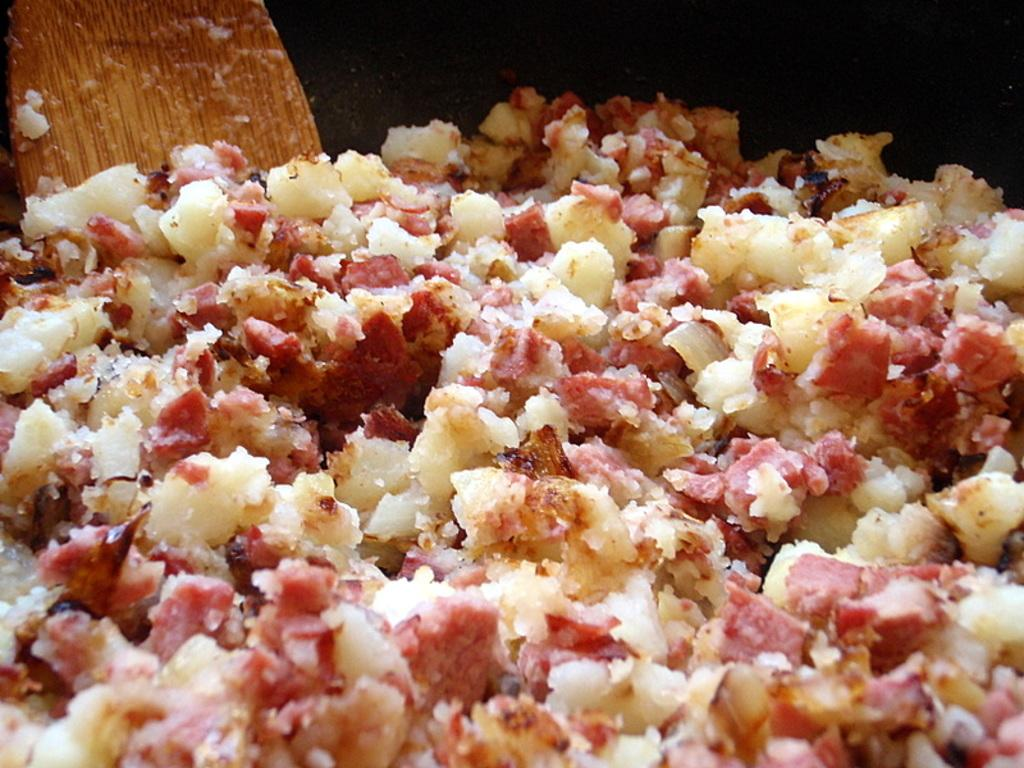What type of pan is visible in the image? There is a black color pan in the image. What is inside the pan? There is food in the pan. What utensil is present in the pan? There is a wooden spoon in the pan. Can you see any mountains in the image? There are no mountains present in the image. What type of cracker is being used to stir the food in the pan? There is no cracker present in the image; it is a wooden spoon that is being used to stir the food. 